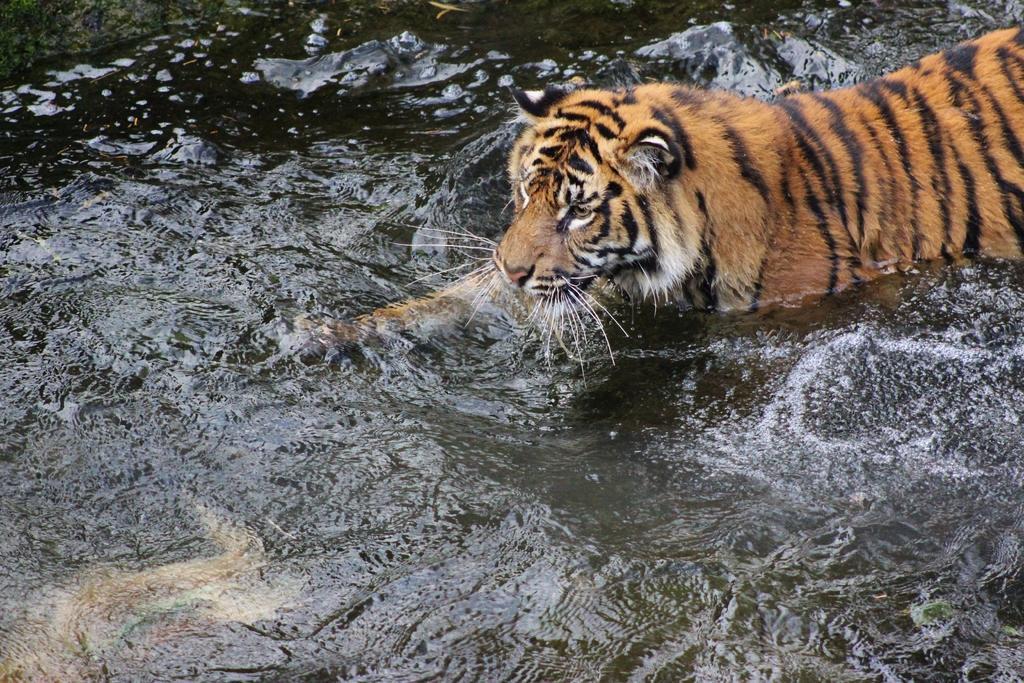Can you describe this image briefly? In this image there is a tiger in the water. 